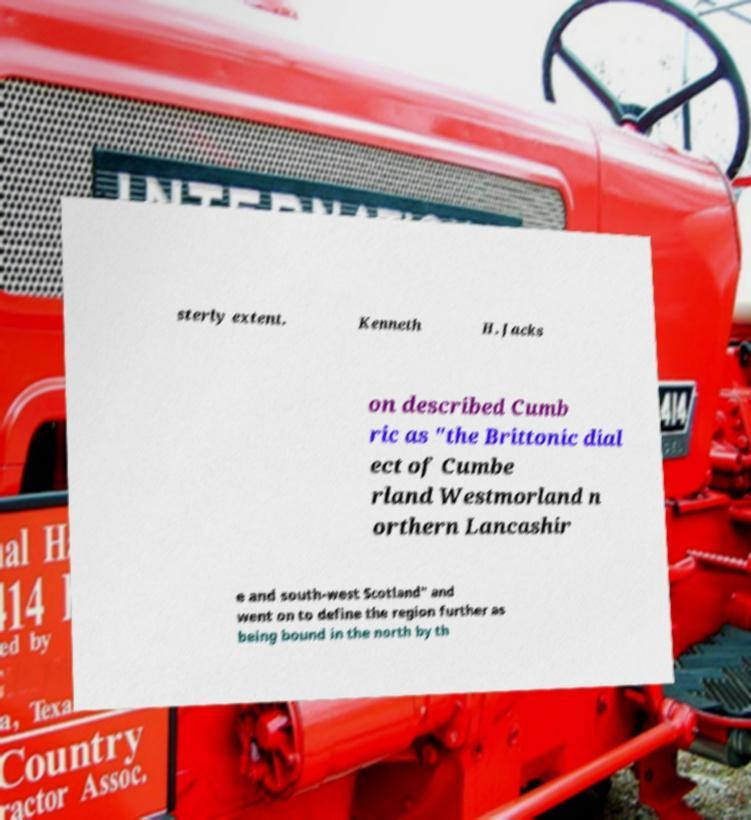Can you read and provide the text displayed in the image?This photo seems to have some interesting text. Can you extract and type it out for me? sterly extent. Kenneth H. Jacks on described Cumb ric as "the Brittonic dial ect of Cumbe rland Westmorland n orthern Lancashir e and south-west Scotland" and went on to define the region further as being bound in the north by th 